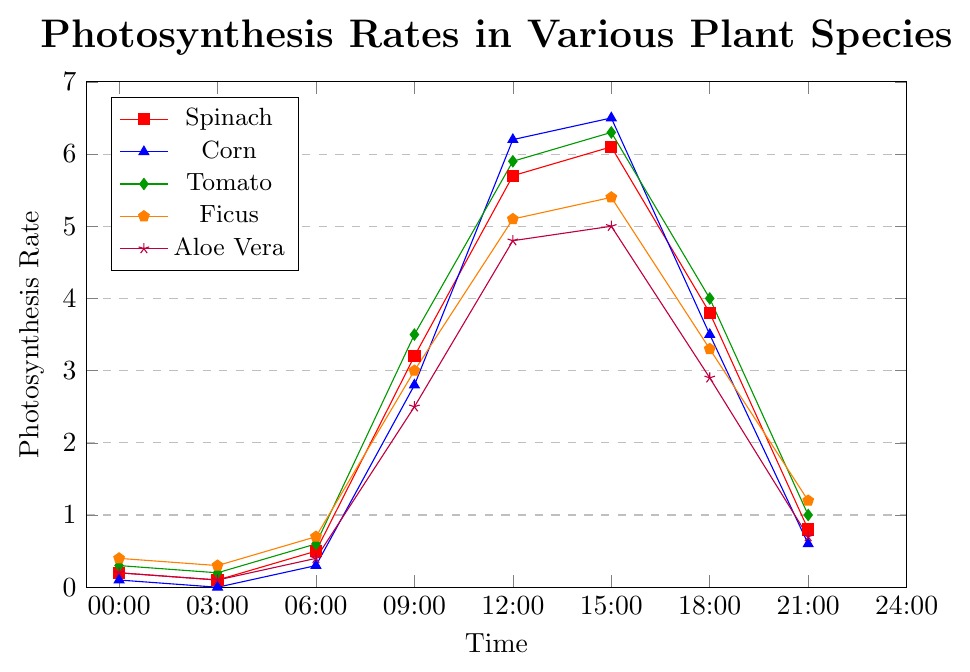Which plant species has the highest photosynthesis rate at 12:00? At 12:00, we observe the y-values for all the plants. Corn has the highest rate at 6.2.
Answer: Corn At which time does Spinach experience its peak photosynthesis rate? Look at the y-values of Spinach across the entire timeline. The highest value is 6.1 at 15:00.
Answer: 15:00 How does the photosynthesis rate of Aloe Vera at 18:00 compare to that of Tomato at the same time? At 18:00, Aloe Vera has a rate of 2.9, while Tomato has a rate of 4.0. Thus, Tomato's rate is higher.
Answer: Tomato's rate is higher What is the average photosynthesis rate of Ficus between 00:00 and 03:00? The rates of Ficus at 00:00 and 03:00 are 0.4 and 0.3 respectively. Average is (0.4 + 0.3) / 2 = 0.35.
Answer: 0.35 What is the difference in photosynthesis rates for Corn between 09:00 and 12:00? Corn's rates at 09:00 and 12:00 are 2.8 and 6.2 respectively. Difference is 6.2 - 2.8 = 3.4.
Answer: 3.4 Which plant species shows the least variation in photosynthesis rate throughout the day? By visually checking all lines, Aloe Vera has relatively smaller changes in y-values throughout the day compared to other plants.
Answer: Aloe Vera What is the total photosynthesis rate of Tomato at 09:00 and 15:00? The rates of Tomato at 09:00 and 15:00 are 3.5 and 6.3 respectively. Sum is 3.5 + 6.3 = 9.8.
Answer: 9.8 Between Spinach and Corn, which plant has a higher photosynthesis rate at 18:00? At 18:00, Spinach has a rate of 3.8 and Corn has a rate of 3.5. Thus, Spinach's rate is higher.
Answer: Spinach's rate is higher 